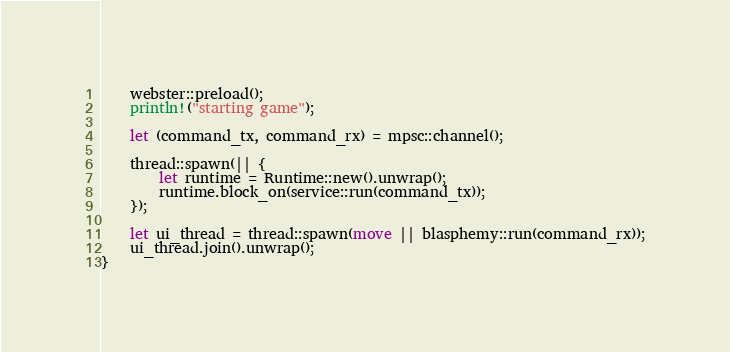<code> <loc_0><loc_0><loc_500><loc_500><_Rust_>	webster::preload();
	println!("starting game");

	let (command_tx, command_rx) = mpsc::channel();

	thread::spawn(|| {
		let runtime = Runtime::new().unwrap();
		runtime.block_on(service::run(command_tx));
	});

	let ui_thread = thread::spawn(move || blasphemy::run(command_rx));
	ui_thread.join().unwrap();
}
</code> 